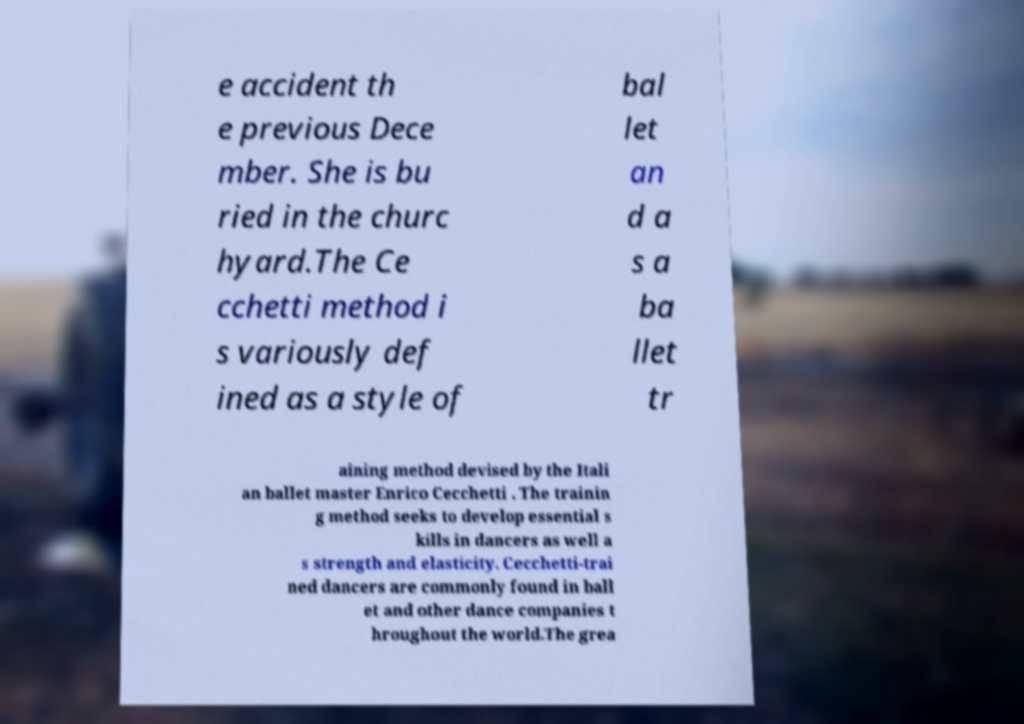What messages or text are displayed in this image? I need them in a readable, typed format. e accident th e previous Dece mber. She is bu ried in the churc hyard.The Ce cchetti method i s variously def ined as a style of bal let an d a s a ba llet tr aining method devised by the Itali an ballet master Enrico Cecchetti . The trainin g method seeks to develop essential s kills in dancers as well a s strength and elasticity. Cecchetti-trai ned dancers are commonly found in ball et and other dance companies t hroughout the world.The grea 